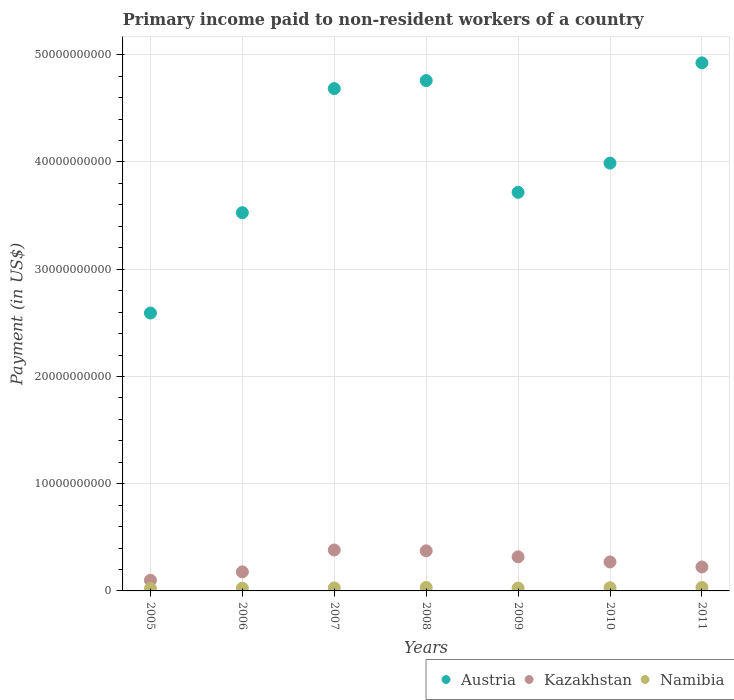What is the amount paid to workers in Austria in 2006?
Provide a short and direct response. 3.53e+1. Across all years, what is the maximum amount paid to workers in Kazakhstan?
Make the answer very short. 3.82e+09. Across all years, what is the minimum amount paid to workers in Austria?
Make the answer very short. 2.59e+1. In which year was the amount paid to workers in Namibia maximum?
Give a very brief answer. 2008. What is the total amount paid to workers in Austria in the graph?
Provide a short and direct response. 2.82e+11. What is the difference between the amount paid to workers in Namibia in 2009 and that in 2010?
Ensure brevity in your answer.  -3.06e+07. What is the difference between the amount paid to workers in Austria in 2009 and the amount paid to workers in Namibia in 2008?
Your answer should be very brief. 3.68e+1. What is the average amount paid to workers in Kazakhstan per year?
Your answer should be very brief. 2.63e+09. In the year 2008, what is the difference between the amount paid to workers in Austria and amount paid to workers in Kazakhstan?
Offer a terse response. 4.38e+1. In how many years, is the amount paid to workers in Namibia greater than 46000000000 US$?
Offer a terse response. 0. What is the ratio of the amount paid to workers in Austria in 2005 to that in 2009?
Provide a succinct answer. 0.7. What is the difference between the highest and the second highest amount paid to workers in Austria?
Ensure brevity in your answer.  1.65e+09. What is the difference between the highest and the lowest amount paid to workers in Kazakhstan?
Ensure brevity in your answer.  2.82e+09. Is the sum of the amount paid to workers in Austria in 2005 and 2009 greater than the maximum amount paid to workers in Kazakhstan across all years?
Offer a very short reply. Yes. Is the amount paid to workers in Namibia strictly greater than the amount paid to workers in Austria over the years?
Your answer should be very brief. No. How many dotlines are there?
Your answer should be very brief. 3. What is the difference between two consecutive major ticks on the Y-axis?
Give a very brief answer. 1.00e+1. Are the values on the major ticks of Y-axis written in scientific E-notation?
Provide a succinct answer. No. Does the graph contain any zero values?
Your response must be concise. No. Does the graph contain grids?
Ensure brevity in your answer.  Yes. Where does the legend appear in the graph?
Provide a short and direct response. Bottom right. How many legend labels are there?
Keep it short and to the point. 3. What is the title of the graph?
Your response must be concise. Primary income paid to non-resident workers of a country. What is the label or title of the Y-axis?
Provide a succinct answer. Payment (in US$). What is the Payment (in US$) of Austria in 2005?
Provide a short and direct response. 2.59e+1. What is the Payment (in US$) in Kazakhstan in 2005?
Offer a very short reply. 9.93e+08. What is the Payment (in US$) in Namibia in 2005?
Offer a very short reply. 2.25e+08. What is the Payment (in US$) of Austria in 2006?
Offer a very short reply. 3.53e+1. What is the Payment (in US$) in Kazakhstan in 2006?
Give a very brief answer. 1.78e+09. What is the Payment (in US$) of Namibia in 2006?
Make the answer very short. 2.56e+08. What is the Payment (in US$) of Austria in 2007?
Your answer should be compact. 4.68e+1. What is the Payment (in US$) in Kazakhstan in 2007?
Offer a very short reply. 3.82e+09. What is the Payment (in US$) of Namibia in 2007?
Provide a short and direct response. 2.77e+08. What is the Payment (in US$) of Austria in 2008?
Provide a short and direct response. 4.76e+1. What is the Payment (in US$) of Kazakhstan in 2008?
Offer a terse response. 3.74e+09. What is the Payment (in US$) in Namibia in 2008?
Make the answer very short. 3.24e+08. What is the Payment (in US$) in Austria in 2009?
Keep it short and to the point. 3.72e+1. What is the Payment (in US$) in Kazakhstan in 2009?
Your answer should be very brief. 3.18e+09. What is the Payment (in US$) of Namibia in 2009?
Your answer should be compact. 2.65e+08. What is the Payment (in US$) in Austria in 2010?
Your answer should be very brief. 3.99e+1. What is the Payment (in US$) in Kazakhstan in 2010?
Provide a succinct answer. 2.70e+09. What is the Payment (in US$) in Namibia in 2010?
Give a very brief answer. 2.96e+08. What is the Payment (in US$) in Austria in 2011?
Keep it short and to the point. 4.92e+1. What is the Payment (in US$) of Kazakhstan in 2011?
Offer a terse response. 2.23e+09. What is the Payment (in US$) in Namibia in 2011?
Your answer should be very brief. 3.19e+08. Across all years, what is the maximum Payment (in US$) of Austria?
Offer a terse response. 4.92e+1. Across all years, what is the maximum Payment (in US$) of Kazakhstan?
Keep it short and to the point. 3.82e+09. Across all years, what is the maximum Payment (in US$) of Namibia?
Offer a terse response. 3.24e+08. Across all years, what is the minimum Payment (in US$) in Austria?
Your answer should be very brief. 2.59e+1. Across all years, what is the minimum Payment (in US$) of Kazakhstan?
Provide a short and direct response. 9.93e+08. Across all years, what is the minimum Payment (in US$) in Namibia?
Offer a very short reply. 2.25e+08. What is the total Payment (in US$) in Austria in the graph?
Give a very brief answer. 2.82e+11. What is the total Payment (in US$) of Kazakhstan in the graph?
Provide a short and direct response. 1.84e+1. What is the total Payment (in US$) in Namibia in the graph?
Your answer should be compact. 1.96e+09. What is the difference between the Payment (in US$) of Austria in 2005 and that in 2006?
Provide a succinct answer. -9.36e+09. What is the difference between the Payment (in US$) in Kazakhstan in 2005 and that in 2006?
Keep it short and to the point. -7.83e+08. What is the difference between the Payment (in US$) in Namibia in 2005 and that in 2006?
Keep it short and to the point. -3.06e+07. What is the difference between the Payment (in US$) in Austria in 2005 and that in 2007?
Your answer should be compact. -2.09e+1. What is the difference between the Payment (in US$) in Kazakhstan in 2005 and that in 2007?
Offer a terse response. -2.82e+09. What is the difference between the Payment (in US$) of Namibia in 2005 and that in 2007?
Your answer should be compact. -5.19e+07. What is the difference between the Payment (in US$) of Austria in 2005 and that in 2008?
Your answer should be compact. -2.17e+1. What is the difference between the Payment (in US$) in Kazakhstan in 2005 and that in 2008?
Offer a very short reply. -2.75e+09. What is the difference between the Payment (in US$) in Namibia in 2005 and that in 2008?
Provide a short and direct response. -9.89e+07. What is the difference between the Payment (in US$) in Austria in 2005 and that in 2009?
Your answer should be compact. -1.13e+1. What is the difference between the Payment (in US$) in Kazakhstan in 2005 and that in 2009?
Offer a very short reply. -2.18e+09. What is the difference between the Payment (in US$) of Namibia in 2005 and that in 2009?
Offer a terse response. -3.96e+07. What is the difference between the Payment (in US$) of Austria in 2005 and that in 2010?
Keep it short and to the point. -1.40e+1. What is the difference between the Payment (in US$) of Kazakhstan in 2005 and that in 2010?
Ensure brevity in your answer.  -1.71e+09. What is the difference between the Payment (in US$) of Namibia in 2005 and that in 2010?
Keep it short and to the point. -7.02e+07. What is the difference between the Payment (in US$) in Austria in 2005 and that in 2011?
Make the answer very short. -2.33e+1. What is the difference between the Payment (in US$) of Kazakhstan in 2005 and that in 2011?
Your response must be concise. -1.24e+09. What is the difference between the Payment (in US$) of Namibia in 2005 and that in 2011?
Your answer should be very brief. -9.40e+07. What is the difference between the Payment (in US$) in Austria in 2006 and that in 2007?
Your answer should be very brief. -1.16e+1. What is the difference between the Payment (in US$) of Kazakhstan in 2006 and that in 2007?
Offer a very short reply. -2.04e+09. What is the difference between the Payment (in US$) of Namibia in 2006 and that in 2007?
Provide a short and direct response. -2.12e+07. What is the difference between the Payment (in US$) in Austria in 2006 and that in 2008?
Provide a succinct answer. -1.23e+1. What is the difference between the Payment (in US$) in Kazakhstan in 2006 and that in 2008?
Ensure brevity in your answer.  -1.96e+09. What is the difference between the Payment (in US$) in Namibia in 2006 and that in 2008?
Keep it short and to the point. -6.83e+07. What is the difference between the Payment (in US$) of Austria in 2006 and that in 2009?
Make the answer very short. -1.90e+09. What is the difference between the Payment (in US$) in Kazakhstan in 2006 and that in 2009?
Your answer should be compact. -1.40e+09. What is the difference between the Payment (in US$) of Namibia in 2006 and that in 2009?
Your answer should be compact. -9.01e+06. What is the difference between the Payment (in US$) in Austria in 2006 and that in 2010?
Give a very brief answer. -4.62e+09. What is the difference between the Payment (in US$) in Kazakhstan in 2006 and that in 2010?
Offer a very short reply. -9.25e+08. What is the difference between the Payment (in US$) of Namibia in 2006 and that in 2010?
Ensure brevity in your answer.  -3.96e+07. What is the difference between the Payment (in US$) in Austria in 2006 and that in 2011?
Provide a short and direct response. -1.40e+1. What is the difference between the Payment (in US$) of Kazakhstan in 2006 and that in 2011?
Offer a very short reply. -4.56e+08. What is the difference between the Payment (in US$) in Namibia in 2006 and that in 2011?
Ensure brevity in your answer.  -6.34e+07. What is the difference between the Payment (in US$) in Austria in 2007 and that in 2008?
Your answer should be very brief. -7.47e+08. What is the difference between the Payment (in US$) in Kazakhstan in 2007 and that in 2008?
Your answer should be compact. 7.49e+07. What is the difference between the Payment (in US$) of Namibia in 2007 and that in 2008?
Your response must be concise. -4.70e+07. What is the difference between the Payment (in US$) in Austria in 2007 and that in 2009?
Ensure brevity in your answer.  9.67e+09. What is the difference between the Payment (in US$) in Kazakhstan in 2007 and that in 2009?
Offer a terse response. 6.37e+08. What is the difference between the Payment (in US$) of Namibia in 2007 and that in 2009?
Provide a short and direct response. 1.22e+07. What is the difference between the Payment (in US$) in Austria in 2007 and that in 2010?
Offer a terse response. 6.95e+09. What is the difference between the Payment (in US$) of Kazakhstan in 2007 and that in 2010?
Provide a short and direct response. 1.11e+09. What is the difference between the Payment (in US$) of Namibia in 2007 and that in 2010?
Ensure brevity in your answer.  -1.83e+07. What is the difference between the Payment (in US$) of Austria in 2007 and that in 2011?
Your response must be concise. -2.40e+09. What is the difference between the Payment (in US$) in Kazakhstan in 2007 and that in 2011?
Your answer should be compact. 1.58e+09. What is the difference between the Payment (in US$) of Namibia in 2007 and that in 2011?
Provide a succinct answer. -4.22e+07. What is the difference between the Payment (in US$) in Austria in 2008 and that in 2009?
Your response must be concise. 1.04e+1. What is the difference between the Payment (in US$) of Kazakhstan in 2008 and that in 2009?
Provide a succinct answer. 5.62e+08. What is the difference between the Payment (in US$) of Namibia in 2008 and that in 2009?
Make the answer very short. 5.92e+07. What is the difference between the Payment (in US$) in Austria in 2008 and that in 2010?
Your response must be concise. 7.70e+09. What is the difference between the Payment (in US$) in Kazakhstan in 2008 and that in 2010?
Make the answer very short. 1.04e+09. What is the difference between the Payment (in US$) of Namibia in 2008 and that in 2010?
Offer a very short reply. 2.87e+07. What is the difference between the Payment (in US$) in Austria in 2008 and that in 2011?
Your answer should be compact. -1.65e+09. What is the difference between the Payment (in US$) in Kazakhstan in 2008 and that in 2011?
Provide a succinct answer. 1.51e+09. What is the difference between the Payment (in US$) in Namibia in 2008 and that in 2011?
Your response must be concise. 4.85e+06. What is the difference between the Payment (in US$) in Austria in 2009 and that in 2010?
Offer a terse response. -2.72e+09. What is the difference between the Payment (in US$) in Kazakhstan in 2009 and that in 2010?
Your response must be concise. 4.77e+08. What is the difference between the Payment (in US$) in Namibia in 2009 and that in 2010?
Offer a very short reply. -3.06e+07. What is the difference between the Payment (in US$) of Austria in 2009 and that in 2011?
Your answer should be very brief. -1.21e+1. What is the difference between the Payment (in US$) of Kazakhstan in 2009 and that in 2011?
Offer a terse response. 9.46e+08. What is the difference between the Payment (in US$) of Namibia in 2009 and that in 2011?
Ensure brevity in your answer.  -5.44e+07. What is the difference between the Payment (in US$) of Austria in 2010 and that in 2011?
Your answer should be compact. -9.35e+09. What is the difference between the Payment (in US$) of Kazakhstan in 2010 and that in 2011?
Offer a terse response. 4.69e+08. What is the difference between the Payment (in US$) in Namibia in 2010 and that in 2011?
Ensure brevity in your answer.  -2.38e+07. What is the difference between the Payment (in US$) of Austria in 2005 and the Payment (in US$) of Kazakhstan in 2006?
Keep it short and to the point. 2.41e+1. What is the difference between the Payment (in US$) of Austria in 2005 and the Payment (in US$) of Namibia in 2006?
Ensure brevity in your answer.  2.57e+1. What is the difference between the Payment (in US$) in Kazakhstan in 2005 and the Payment (in US$) in Namibia in 2006?
Provide a succinct answer. 7.37e+08. What is the difference between the Payment (in US$) of Austria in 2005 and the Payment (in US$) of Kazakhstan in 2007?
Ensure brevity in your answer.  2.21e+1. What is the difference between the Payment (in US$) of Austria in 2005 and the Payment (in US$) of Namibia in 2007?
Your response must be concise. 2.56e+1. What is the difference between the Payment (in US$) of Kazakhstan in 2005 and the Payment (in US$) of Namibia in 2007?
Your answer should be very brief. 7.16e+08. What is the difference between the Payment (in US$) of Austria in 2005 and the Payment (in US$) of Kazakhstan in 2008?
Make the answer very short. 2.22e+1. What is the difference between the Payment (in US$) in Austria in 2005 and the Payment (in US$) in Namibia in 2008?
Keep it short and to the point. 2.56e+1. What is the difference between the Payment (in US$) in Kazakhstan in 2005 and the Payment (in US$) in Namibia in 2008?
Offer a very short reply. 6.69e+08. What is the difference between the Payment (in US$) of Austria in 2005 and the Payment (in US$) of Kazakhstan in 2009?
Your answer should be very brief. 2.27e+1. What is the difference between the Payment (in US$) of Austria in 2005 and the Payment (in US$) of Namibia in 2009?
Your response must be concise. 2.56e+1. What is the difference between the Payment (in US$) in Kazakhstan in 2005 and the Payment (in US$) in Namibia in 2009?
Provide a short and direct response. 7.28e+08. What is the difference between the Payment (in US$) of Austria in 2005 and the Payment (in US$) of Kazakhstan in 2010?
Give a very brief answer. 2.32e+1. What is the difference between the Payment (in US$) in Austria in 2005 and the Payment (in US$) in Namibia in 2010?
Provide a succinct answer. 2.56e+1. What is the difference between the Payment (in US$) of Kazakhstan in 2005 and the Payment (in US$) of Namibia in 2010?
Keep it short and to the point. 6.98e+08. What is the difference between the Payment (in US$) in Austria in 2005 and the Payment (in US$) in Kazakhstan in 2011?
Give a very brief answer. 2.37e+1. What is the difference between the Payment (in US$) in Austria in 2005 and the Payment (in US$) in Namibia in 2011?
Your answer should be very brief. 2.56e+1. What is the difference between the Payment (in US$) in Kazakhstan in 2005 and the Payment (in US$) in Namibia in 2011?
Keep it short and to the point. 6.74e+08. What is the difference between the Payment (in US$) in Austria in 2006 and the Payment (in US$) in Kazakhstan in 2007?
Your response must be concise. 3.15e+1. What is the difference between the Payment (in US$) in Austria in 2006 and the Payment (in US$) in Namibia in 2007?
Give a very brief answer. 3.50e+1. What is the difference between the Payment (in US$) in Kazakhstan in 2006 and the Payment (in US$) in Namibia in 2007?
Your answer should be compact. 1.50e+09. What is the difference between the Payment (in US$) in Austria in 2006 and the Payment (in US$) in Kazakhstan in 2008?
Make the answer very short. 3.15e+1. What is the difference between the Payment (in US$) in Austria in 2006 and the Payment (in US$) in Namibia in 2008?
Provide a succinct answer. 3.49e+1. What is the difference between the Payment (in US$) in Kazakhstan in 2006 and the Payment (in US$) in Namibia in 2008?
Provide a succinct answer. 1.45e+09. What is the difference between the Payment (in US$) of Austria in 2006 and the Payment (in US$) of Kazakhstan in 2009?
Offer a terse response. 3.21e+1. What is the difference between the Payment (in US$) in Austria in 2006 and the Payment (in US$) in Namibia in 2009?
Keep it short and to the point. 3.50e+1. What is the difference between the Payment (in US$) of Kazakhstan in 2006 and the Payment (in US$) of Namibia in 2009?
Ensure brevity in your answer.  1.51e+09. What is the difference between the Payment (in US$) of Austria in 2006 and the Payment (in US$) of Kazakhstan in 2010?
Provide a succinct answer. 3.26e+1. What is the difference between the Payment (in US$) of Austria in 2006 and the Payment (in US$) of Namibia in 2010?
Your answer should be very brief. 3.50e+1. What is the difference between the Payment (in US$) in Kazakhstan in 2006 and the Payment (in US$) in Namibia in 2010?
Provide a succinct answer. 1.48e+09. What is the difference between the Payment (in US$) in Austria in 2006 and the Payment (in US$) in Kazakhstan in 2011?
Ensure brevity in your answer.  3.30e+1. What is the difference between the Payment (in US$) of Austria in 2006 and the Payment (in US$) of Namibia in 2011?
Your response must be concise. 3.50e+1. What is the difference between the Payment (in US$) of Kazakhstan in 2006 and the Payment (in US$) of Namibia in 2011?
Ensure brevity in your answer.  1.46e+09. What is the difference between the Payment (in US$) of Austria in 2007 and the Payment (in US$) of Kazakhstan in 2008?
Keep it short and to the point. 4.31e+1. What is the difference between the Payment (in US$) in Austria in 2007 and the Payment (in US$) in Namibia in 2008?
Provide a short and direct response. 4.65e+1. What is the difference between the Payment (in US$) of Kazakhstan in 2007 and the Payment (in US$) of Namibia in 2008?
Your response must be concise. 3.49e+09. What is the difference between the Payment (in US$) in Austria in 2007 and the Payment (in US$) in Kazakhstan in 2009?
Your response must be concise. 4.37e+1. What is the difference between the Payment (in US$) of Austria in 2007 and the Payment (in US$) of Namibia in 2009?
Keep it short and to the point. 4.66e+1. What is the difference between the Payment (in US$) of Kazakhstan in 2007 and the Payment (in US$) of Namibia in 2009?
Make the answer very short. 3.55e+09. What is the difference between the Payment (in US$) of Austria in 2007 and the Payment (in US$) of Kazakhstan in 2010?
Keep it short and to the point. 4.41e+1. What is the difference between the Payment (in US$) in Austria in 2007 and the Payment (in US$) in Namibia in 2010?
Your response must be concise. 4.65e+1. What is the difference between the Payment (in US$) of Kazakhstan in 2007 and the Payment (in US$) of Namibia in 2010?
Ensure brevity in your answer.  3.52e+09. What is the difference between the Payment (in US$) in Austria in 2007 and the Payment (in US$) in Kazakhstan in 2011?
Ensure brevity in your answer.  4.46e+1. What is the difference between the Payment (in US$) of Austria in 2007 and the Payment (in US$) of Namibia in 2011?
Your answer should be very brief. 4.65e+1. What is the difference between the Payment (in US$) in Kazakhstan in 2007 and the Payment (in US$) in Namibia in 2011?
Offer a terse response. 3.50e+09. What is the difference between the Payment (in US$) of Austria in 2008 and the Payment (in US$) of Kazakhstan in 2009?
Your answer should be compact. 4.44e+1. What is the difference between the Payment (in US$) in Austria in 2008 and the Payment (in US$) in Namibia in 2009?
Your answer should be compact. 4.73e+1. What is the difference between the Payment (in US$) of Kazakhstan in 2008 and the Payment (in US$) of Namibia in 2009?
Keep it short and to the point. 3.48e+09. What is the difference between the Payment (in US$) in Austria in 2008 and the Payment (in US$) in Kazakhstan in 2010?
Offer a very short reply. 4.49e+1. What is the difference between the Payment (in US$) of Austria in 2008 and the Payment (in US$) of Namibia in 2010?
Ensure brevity in your answer.  4.73e+1. What is the difference between the Payment (in US$) in Kazakhstan in 2008 and the Payment (in US$) in Namibia in 2010?
Provide a succinct answer. 3.44e+09. What is the difference between the Payment (in US$) in Austria in 2008 and the Payment (in US$) in Kazakhstan in 2011?
Offer a terse response. 4.54e+1. What is the difference between the Payment (in US$) of Austria in 2008 and the Payment (in US$) of Namibia in 2011?
Provide a short and direct response. 4.73e+1. What is the difference between the Payment (in US$) of Kazakhstan in 2008 and the Payment (in US$) of Namibia in 2011?
Your answer should be very brief. 3.42e+09. What is the difference between the Payment (in US$) of Austria in 2009 and the Payment (in US$) of Kazakhstan in 2010?
Your response must be concise. 3.45e+1. What is the difference between the Payment (in US$) in Austria in 2009 and the Payment (in US$) in Namibia in 2010?
Offer a terse response. 3.69e+1. What is the difference between the Payment (in US$) of Kazakhstan in 2009 and the Payment (in US$) of Namibia in 2010?
Provide a short and direct response. 2.88e+09. What is the difference between the Payment (in US$) of Austria in 2009 and the Payment (in US$) of Kazakhstan in 2011?
Your answer should be compact. 3.49e+1. What is the difference between the Payment (in US$) of Austria in 2009 and the Payment (in US$) of Namibia in 2011?
Keep it short and to the point. 3.69e+1. What is the difference between the Payment (in US$) in Kazakhstan in 2009 and the Payment (in US$) in Namibia in 2011?
Your response must be concise. 2.86e+09. What is the difference between the Payment (in US$) of Austria in 2010 and the Payment (in US$) of Kazakhstan in 2011?
Provide a short and direct response. 3.77e+1. What is the difference between the Payment (in US$) of Austria in 2010 and the Payment (in US$) of Namibia in 2011?
Ensure brevity in your answer.  3.96e+1. What is the difference between the Payment (in US$) of Kazakhstan in 2010 and the Payment (in US$) of Namibia in 2011?
Make the answer very short. 2.38e+09. What is the average Payment (in US$) of Austria per year?
Provide a short and direct response. 4.03e+1. What is the average Payment (in US$) in Kazakhstan per year?
Make the answer very short. 2.63e+09. What is the average Payment (in US$) of Namibia per year?
Offer a very short reply. 2.80e+08. In the year 2005, what is the difference between the Payment (in US$) in Austria and Payment (in US$) in Kazakhstan?
Offer a terse response. 2.49e+1. In the year 2005, what is the difference between the Payment (in US$) of Austria and Payment (in US$) of Namibia?
Make the answer very short. 2.57e+1. In the year 2005, what is the difference between the Payment (in US$) in Kazakhstan and Payment (in US$) in Namibia?
Keep it short and to the point. 7.68e+08. In the year 2006, what is the difference between the Payment (in US$) in Austria and Payment (in US$) in Kazakhstan?
Provide a short and direct response. 3.35e+1. In the year 2006, what is the difference between the Payment (in US$) of Austria and Payment (in US$) of Namibia?
Provide a succinct answer. 3.50e+1. In the year 2006, what is the difference between the Payment (in US$) in Kazakhstan and Payment (in US$) in Namibia?
Your answer should be compact. 1.52e+09. In the year 2007, what is the difference between the Payment (in US$) of Austria and Payment (in US$) of Kazakhstan?
Provide a short and direct response. 4.30e+1. In the year 2007, what is the difference between the Payment (in US$) in Austria and Payment (in US$) in Namibia?
Your response must be concise. 4.66e+1. In the year 2007, what is the difference between the Payment (in US$) of Kazakhstan and Payment (in US$) of Namibia?
Your response must be concise. 3.54e+09. In the year 2008, what is the difference between the Payment (in US$) of Austria and Payment (in US$) of Kazakhstan?
Make the answer very short. 4.38e+1. In the year 2008, what is the difference between the Payment (in US$) in Austria and Payment (in US$) in Namibia?
Your response must be concise. 4.73e+1. In the year 2008, what is the difference between the Payment (in US$) in Kazakhstan and Payment (in US$) in Namibia?
Keep it short and to the point. 3.42e+09. In the year 2009, what is the difference between the Payment (in US$) of Austria and Payment (in US$) of Kazakhstan?
Ensure brevity in your answer.  3.40e+1. In the year 2009, what is the difference between the Payment (in US$) in Austria and Payment (in US$) in Namibia?
Your response must be concise. 3.69e+1. In the year 2009, what is the difference between the Payment (in US$) of Kazakhstan and Payment (in US$) of Namibia?
Ensure brevity in your answer.  2.91e+09. In the year 2010, what is the difference between the Payment (in US$) in Austria and Payment (in US$) in Kazakhstan?
Ensure brevity in your answer.  3.72e+1. In the year 2010, what is the difference between the Payment (in US$) in Austria and Payment (in US$) in Namibia?
Keep it short and to the point. 3.96e+1. In the year 2010, what is the difference between the Payment (in US$) in Kazakhstan and Payment (in US$) in Namibia?
Keep it short and to the point. 2.41e+09. In the year 2011, what is the difference between the Payment (in US$) in Austria and Payment (in US$) in Kazakhstan?
Provide a short and direct response. 4.70e+1. In the year 2011, what is the difference between the Payment (in US$) of Austria and Payment (in US$) of Namibia?
Make the answer very short. 4.89e+1. In the year 2011, what is the difference between the Payment (in US$) in Kazakhstan and Payment (in US$) in Namibia?
Provide a short and direct response. 1.91e+09. What is the ratio of the Payment (in US$) of Austria in 2005 to that in 2006?
Provide a short and direct response. 0.73. What is the ratio of the Payment (in US$) in Kazakhstan in 2005 to that in 2006?
Provide a short and direct response. 0.56. What is the ratio of the Payment (in US$) in Namibia in 2005 to that in 2006?
Your response must be concise. 0.88. What is the ratio of the Payment (in US$) of Austria in 2005 to that in 2007?
Offer a very short reply. 0.55. What is the ratio of the Payment (in US$) of Kazakhstan in 2005 to that in 2007?
Offer a terse response. 0.26. What is the ratio of the Payment (in US$) in Namibia in 2005 to that in 2007?
Ensure brevity in your answer.  0.81. What is the ratio of the Payment (in US$) in Austria in 2005 to that in 2008?
Ensure brevity in your answer.  0.54. What is the ratio of the Payment (in US$) of Kazakhstan in 2005 to that in 2008?
Give a very brief answer. 0.27. What is the ratio of the Payment (in US$) in Namibia in 2005 to that in 2008?
Keep it short and to the point. 0.7. What is the ratio of the Payment (in US$) of Austria in 2005 to that in 2009?
Your answer should be very brief. 0.7. What is the ratio of the Payment (in US$) in Kazakhstan in 2005 to that in 2009?
Offer a terse response. 0.31. What is the ratio of the Payment (in US$) of Namibia in 2005 to that in 2009?
Give a very brief answer. 0.85. What is the ratio of the Payment (in US$) of Austria in 2005 to that in 2010?
Offer a terse response. 0.65. What is the ratio of the Payment (in US$) of Kazakhstan in 2005 to that in 2010?
Ensure brevity in your answer.  0.37. What is the ratio of the Payment (in US$) of Namibia in 2005 to that in 2010?
Provide a short and direct response. 0.76. What is the ratio of the Payment (in US$) in Austria in 2005 to that in 2011?
Your answer should be compact. 0.53. What is the ratio of the Payment (in US$) of Kazakhstan in 2005 to that in 2011?
Give a very brief answer. 0.45. What is the ratio of the Payment (in US$) in Namibia in 2005 to that in 2011?
Offer a terse response. 0.71. What is the ratio of the Payment (in US$) in Austria in 2006 to that in 2007?
Your answer should be very brief. 0.75. What is the ratio of the Payment (in US$) in Kazakhstan in 2006 to that in 2007?
Keep it short and to the point. 0.47. What is the ratio of the Payment (in US$) in Namibia in 2006 to that in 2007?
Provide a succinct answer. 0.92. What is the ratio of the Payment (in US$) of Austria in 2006 to that in 2008?
Ensure brevity in your answer.  0.74. What is the ratio of the Payment (in US$) in Kazakhstan in 2006 to that in 2008?
Offer a very short reply. 0.47. What is the ratio of the Payment (in US$) in Namibia in 2006 to that in 2008?
Give a very brief answer. 0.79. What is the ratio of the Payment (in US$) of Austria in 2006 to that in 2009?
Offer a very short reply. 0.95. What is the ratio of the Payment (in US$) of Kazakhstan in 2006 to that in 2009?
Your answer should be very brief. 0.56. What is the ratio of the Payment (in US$) in Namibia in 2006 to that in 2009?
Your response must be concise. 0.97. What is the ratio of the Payment (in US$) in Austria in 2006 to that in 2010?
Offer a very short reply. 0.88. What is the ratio of the Payment (in US$) of Kazakhstan in 2006 to that in 2010?
Make the answer very short. 0.66. What is the ratio of the Payment (in US$) of Namibia in 2006 to that in 2010?
Keep it short and to the point. 0.87. What is the ratio of the Payment (in US$) of Austria in 2006 to that in 2011?
Keep it short and to the point. 0.72. What is the ratio of the Payment (in US$) of Kazakhstan in 2006 to that in 2011?
Provide a succinct answer. 0.8. What is the ratio of the Payment (in US$) in Namibia in 2006 to that in 2011?
Offer a terse response. 0.8. What is the ratio of the Payment (in US$) of Austria in 2007 to that in 2008?
Your answer should be very brief. 0.98. What is the ratio of the Payment (in US$) of Kazakhstan in 2007 to that in 2008?
Offer a very short reply. 1.02. What is the ratio of the Payment (in US$) of Namibia in 2007 to that in 2008?
Give a very brief answer. 0.85. What is the ratio of the Payment (in US$) of Austria in 2007 to that in 2009?
Provide a short and direct response. 1.26. What is the ratio of the Payment (in US$) in Kazakhstan in 2007 to that in 2009?
Keep it short and to the point. 1.2. What is the ratio of the Payment (in US$) of Namibia in 2007 to that in 2009?
Your response must be concise. 1.05. What is the ratio of the Payment (in US$) in Austria in 2007 to that in 2010?
Your response must be concise. 1.17. What is the ratio of the Payment (in US$) in Kazakhstan in 2007 to that in 2010?
Offer a terse response. 1.41. What is the ratio of the Payment (in US$) of Namibia in 2007 to that in 2010?
Provide a succinct answer. 0.94. What is the ratio of the Payment (in US$) of Austria in 2007 to that in 2011?
Keep it short and to the point. 0.95. What is the ratio of the Payment (in US$) in Kazakhstan in 2007 to that in 2011?
Offer a very short reply. 1.71. What is the ratio of the Payment (in US$) in Namibia in 2007 to that in 2011?
Provide a succinct answer. 0.87. What is the ratio of the Payment (in US$) of Austria in 2008 to that in 2009?
Offer a very short reply. 1.28. What is the ratio of the Payment (in US$) in Kazakhstan in 2008 to that in 2009?
Provide a short and direct response. 1.18. What is the ratio of the Payment (in US$) of Namibia in 2008 to that in 2009?
Offer a terse response. 1.22. What is the ratio of the Payment (in US$) of Austria in 2008 to that in 2010?
Keep it short and to the point. 1.19. What is the ratio of the Payment (in US$) in Kazakhstan in 2008 to that in 2010?
Provide a short and direct response. 1.38. What is the ratio of the Payment (in US$) of Namibia in 2008 to that in 2010?
Keep it short and to the point. 1.1. What is the ratio of the Payment (in US$) of Austria in 2008 to that in 2011?
Offer a very short reply. 0.97. What is the ratio of the Payment (in US$) of Kazakhstan in 2008 to that in 2011?
Your answer should be very brief. 1.68. What is the ratio of the Payment (in US$) in Namibia in 2008 to that in 2011?
Offer a terse response. 1.02. What is the ratio of the Payment (in US$) in Austria in 2009 to that in 2010?
Offer a very short reply. 0.93. What is the ratio of the Payment (in US$) in Kazakhstan in 2009 to that in 2010?
Make the answer very short. 1.18. What is the ratio of the Payment (in US$) of Namibia in 2009 to that in 2010?
Make the answer very short. 0.9. What is the ratio of the Payment (in US$) of Austria in 2009 to that in 2011?
Make the answer very short. 0.75. What is the ratio of the Payment (in US$) of Kazakhstan in 2009 to that in 2011?
Ensure brevity in your answer.  1.42. What is the ratio of the Payment (in US$) in Namibia in 2009 to that in 2011?
Keep it short and to the point. 0.83. What is the ratio of the Payment (in US$) in Austria in 2010 to that in 2011?
Give a very brief answer. 0.81. What is the ratio of the Payment (in US$) of Kazakhstan in 2010 to that in 2011?
Offer a terse response. 1.21. What is the ratio of the Payment (in US$) in Namibia in 2010 to that in 2011?
Your answer should be very brief. 0.93. What is the difference between the highest and the second highest Payment (in US$) of Austria?
Keep it short and to the point. 1.65e+09. What is the difference between the highest and the second highest Payment (in US$) in Kazakhstan?
Your response must be concise. 7.49e+07. What is the difference between the highest and the second highest Payment (in US$) of Namibia?
Make the answer very short. 4.85e+06. What is the difference between the highest and the lowest Payment (in US$) of Austria?
Your response must be concise. 2.33e+1. What is the difference between the highest and the lowest Payment (in US$) of Kazakhstan?
Offer a very short reply. 2.82e+09. What is the difference between the highest and the lowest Payment (in US$) in Namibia?
Offer a very short reply. 9.89e+07. 